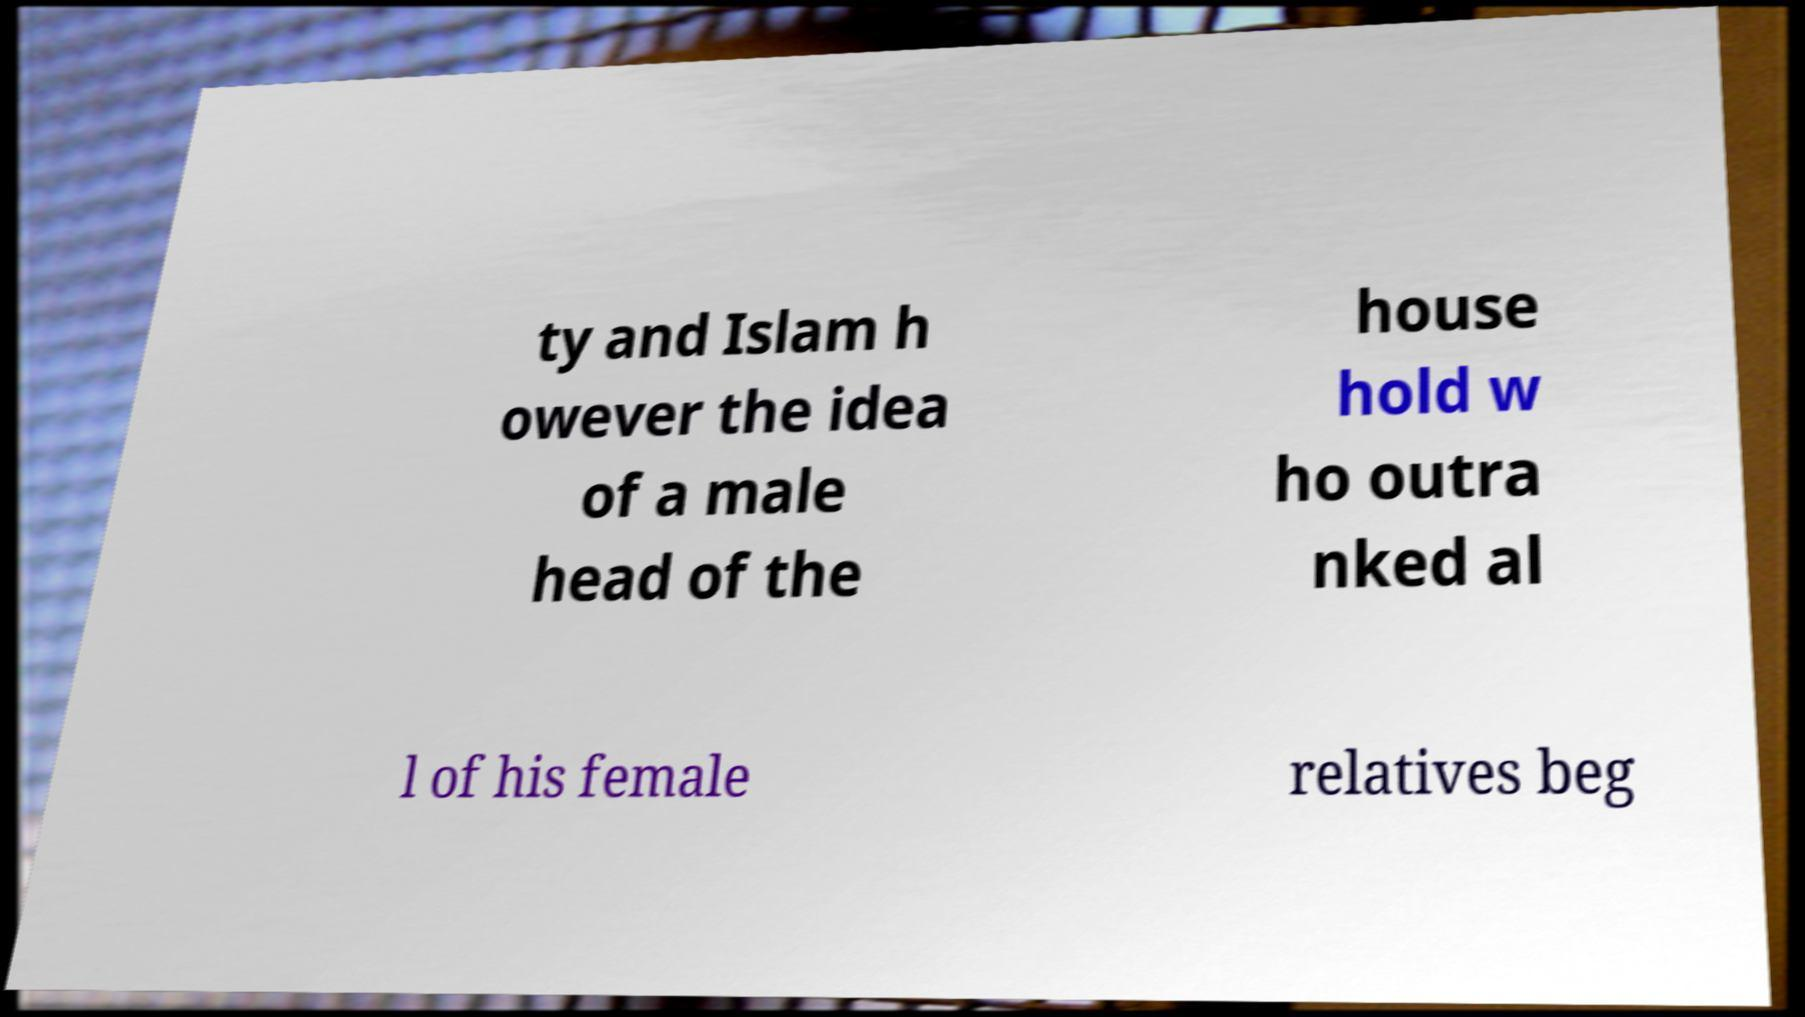Can you accurately transcribe the text from the provided image for me? ty and Islam h owever the idea of a male head of the house hold w ho outra nked al l of his female relatives beg 